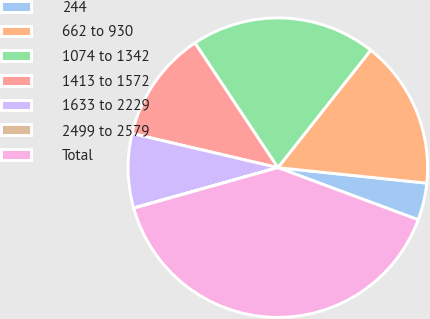<chart> <loc_0><loc_0><loc_500><loc_500><pie_chart><fcel>244<fcel>662 to 930<fcel>1074 to 1342<fcel>1413 to 1572<fcel>1633 to 2229<fcel>2499 to 2579<fcel>Total<nl><fcel>4.01%<fcel>16.0%<fcel>19.99%<fcel>12.0%<fcel>8.01%<fcel>0.02%<fcel>39.97%<nl></chart> 